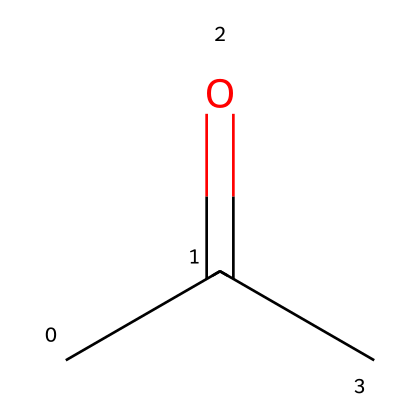How many carbon atoms are in acetone? The SMILES representation indicates the presence of two "C" (carbon) atoms in the main chain and one "C" (carbon) in a methyl group, totaling three carbon atoms.
Answer: three What is the functional group present in acetone? The structure shows a carbonyl group (C=O) which is characteristic of ketones. Since acetone is a ketone, the functional group is the carbonyl group.
Answer: carbonyl How many hydrogen atoms are in acetone? Each carbon forms specific bonds with hydrogen atoms. The central carbon (in the carbonyl) has no hydrogen because it is double-bonded to oxygen, while the two terminal carbons are each bonded to three hydrogens, totaling six hydrogens.
Answer: six What type of molecular structure does acetone represent? Acetone, with its carbonyl formation and the arrangement of carbon and hydrogen, is classified as a ketone because it contains the carbonyl group flanked by carbon atoms on both sides.
Answer: ketone Why is acetone effective as a solvent for removing makeup? The presence of the polar carbonyl group allows acetone to effectively solvate and interact with organic compounds in makeup, breaking apart non-polar substances due to its solvent characteristics.
Answer: polar solvent 